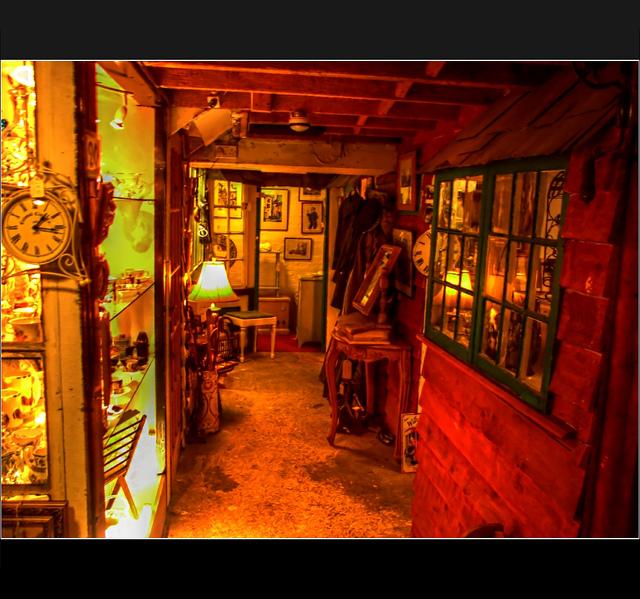Where is the clock?
Keep it brief. Left. What color is the window frame?
Concise answer only. Green. Where is the lamp?
Quick response, please. In hallway. 